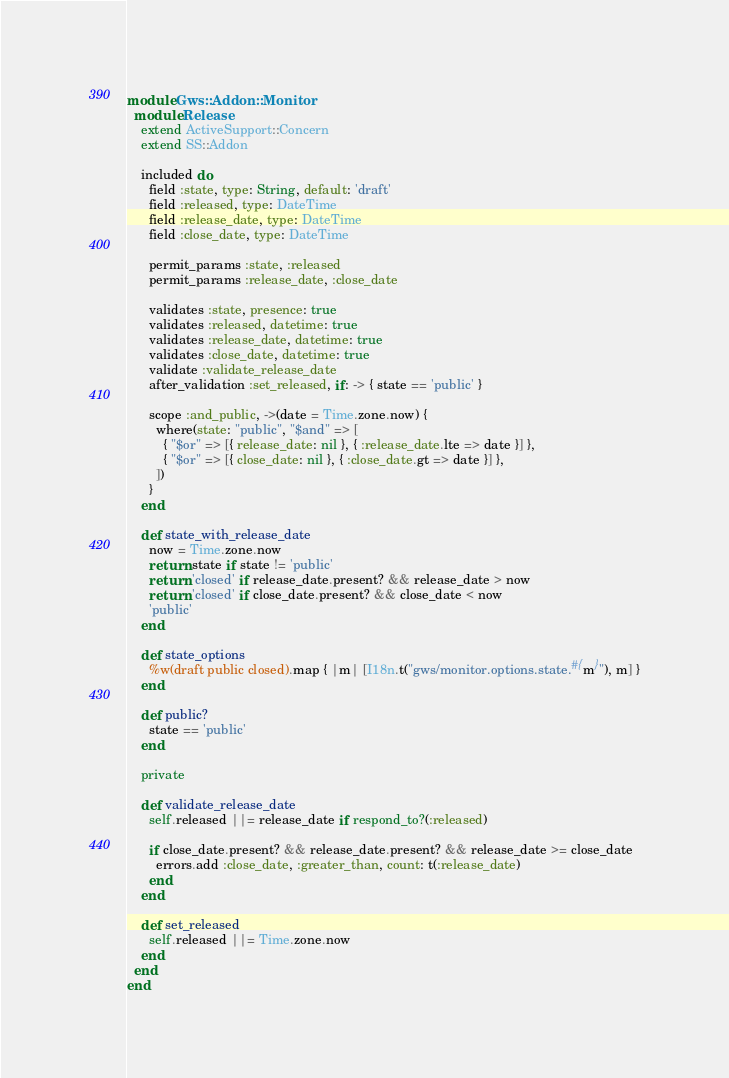<code> <loc_0><loc_0><loc_500><loc_500><_Ruby_>module Gws::Addon::Monitor
  module Release
    extend ActiveSupport::Concern
    extend SS::Addon

    included do
      field :state, type: String, default: 'draft'
      field :released, type: DateTime
      field :release_date, type: DateTime
      field :close_date, type: DateTime

      permit_params :state, :released
      permit_params :release_date, :close_date

      validates :state, presence: true
      validates :released, datetime: true
      validates :release_date, datetime: true
      validates :close_date, datetime: true
      validate :validate_release_date
      after_validation :set_released, if: -> { state == 'public' }

      scope :and_public, ->(date = Time.zone.now) {
        where(state: "public", "$and" => [
          { "$or" => [{ release_date: nil }, { :release_date.lte => date }] },
          { "$or" => [{ close_date: nil }, { :close_date.gt => date }] },
        ])
      }
    end

    def state_with_release_date
      now = Time.zone.now
      return state if state != 'public'
      return 'closed' if release_date.present? && release_date > now
      return 'closed' if close_date.present? && close_date < now
      'public'
    end

    def state_options
      %w(draft public closed).map { |m| [I18n.t("gws/monitor.options.state.#{m}"), m] }
    end

    def public?
      state == 'public'
    end

    private

    def validate_release_date
      self.released ||= release_date if respond_to?(:released)

      if close_date.present? && release_date.present? && release_date >= close_date
        errors.add :close_date, :greater_than, count: t(:release_date)
      end
    end

    def set_released
      self.released ||= Time.zone.now
    end
  end
end
</code> 